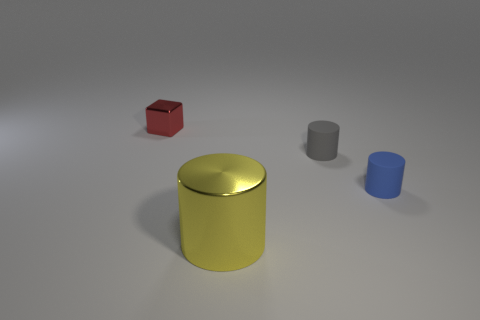What number of other things are there of the same color as the big object?
Ensure brevity in your answer.  0. Is the small cylinder that is to the left of the blue matte object made of the same material as the small blue thing?
Offer a terse response. Yes. Is the number of blue rubber cylinders on the left side of the small gray rubber cylinder less than the number of red objects right of the tiny blue matte cylinder?
Provide a succinct answer. No. How many other things are there of the same material as the gray cylinder?
Your answer should be very brief. 1. There is a red block that is the same size as the blue object; what material is it?
Offer a very short reply. Metal. Are there fewer rubber objects that are on the left side of the big yellow thing than tiny blue things?
Offer a terse response. Yes. What shape is the metal thing behind the metallic thing that is on the right side of the tiny object to the left of the big thing?
Your answer should be compact. Cube. What is the size of the metal thing in front of the red thing?
Your response must be concise. Large. What shape is the red metal thing that is the same size as the gray rubber thing?
Your response must be concise. Cube. How many objects are either big red spheres or metallic objects on the right side of the red shiny thing?
Offer a very short reply. 1. 